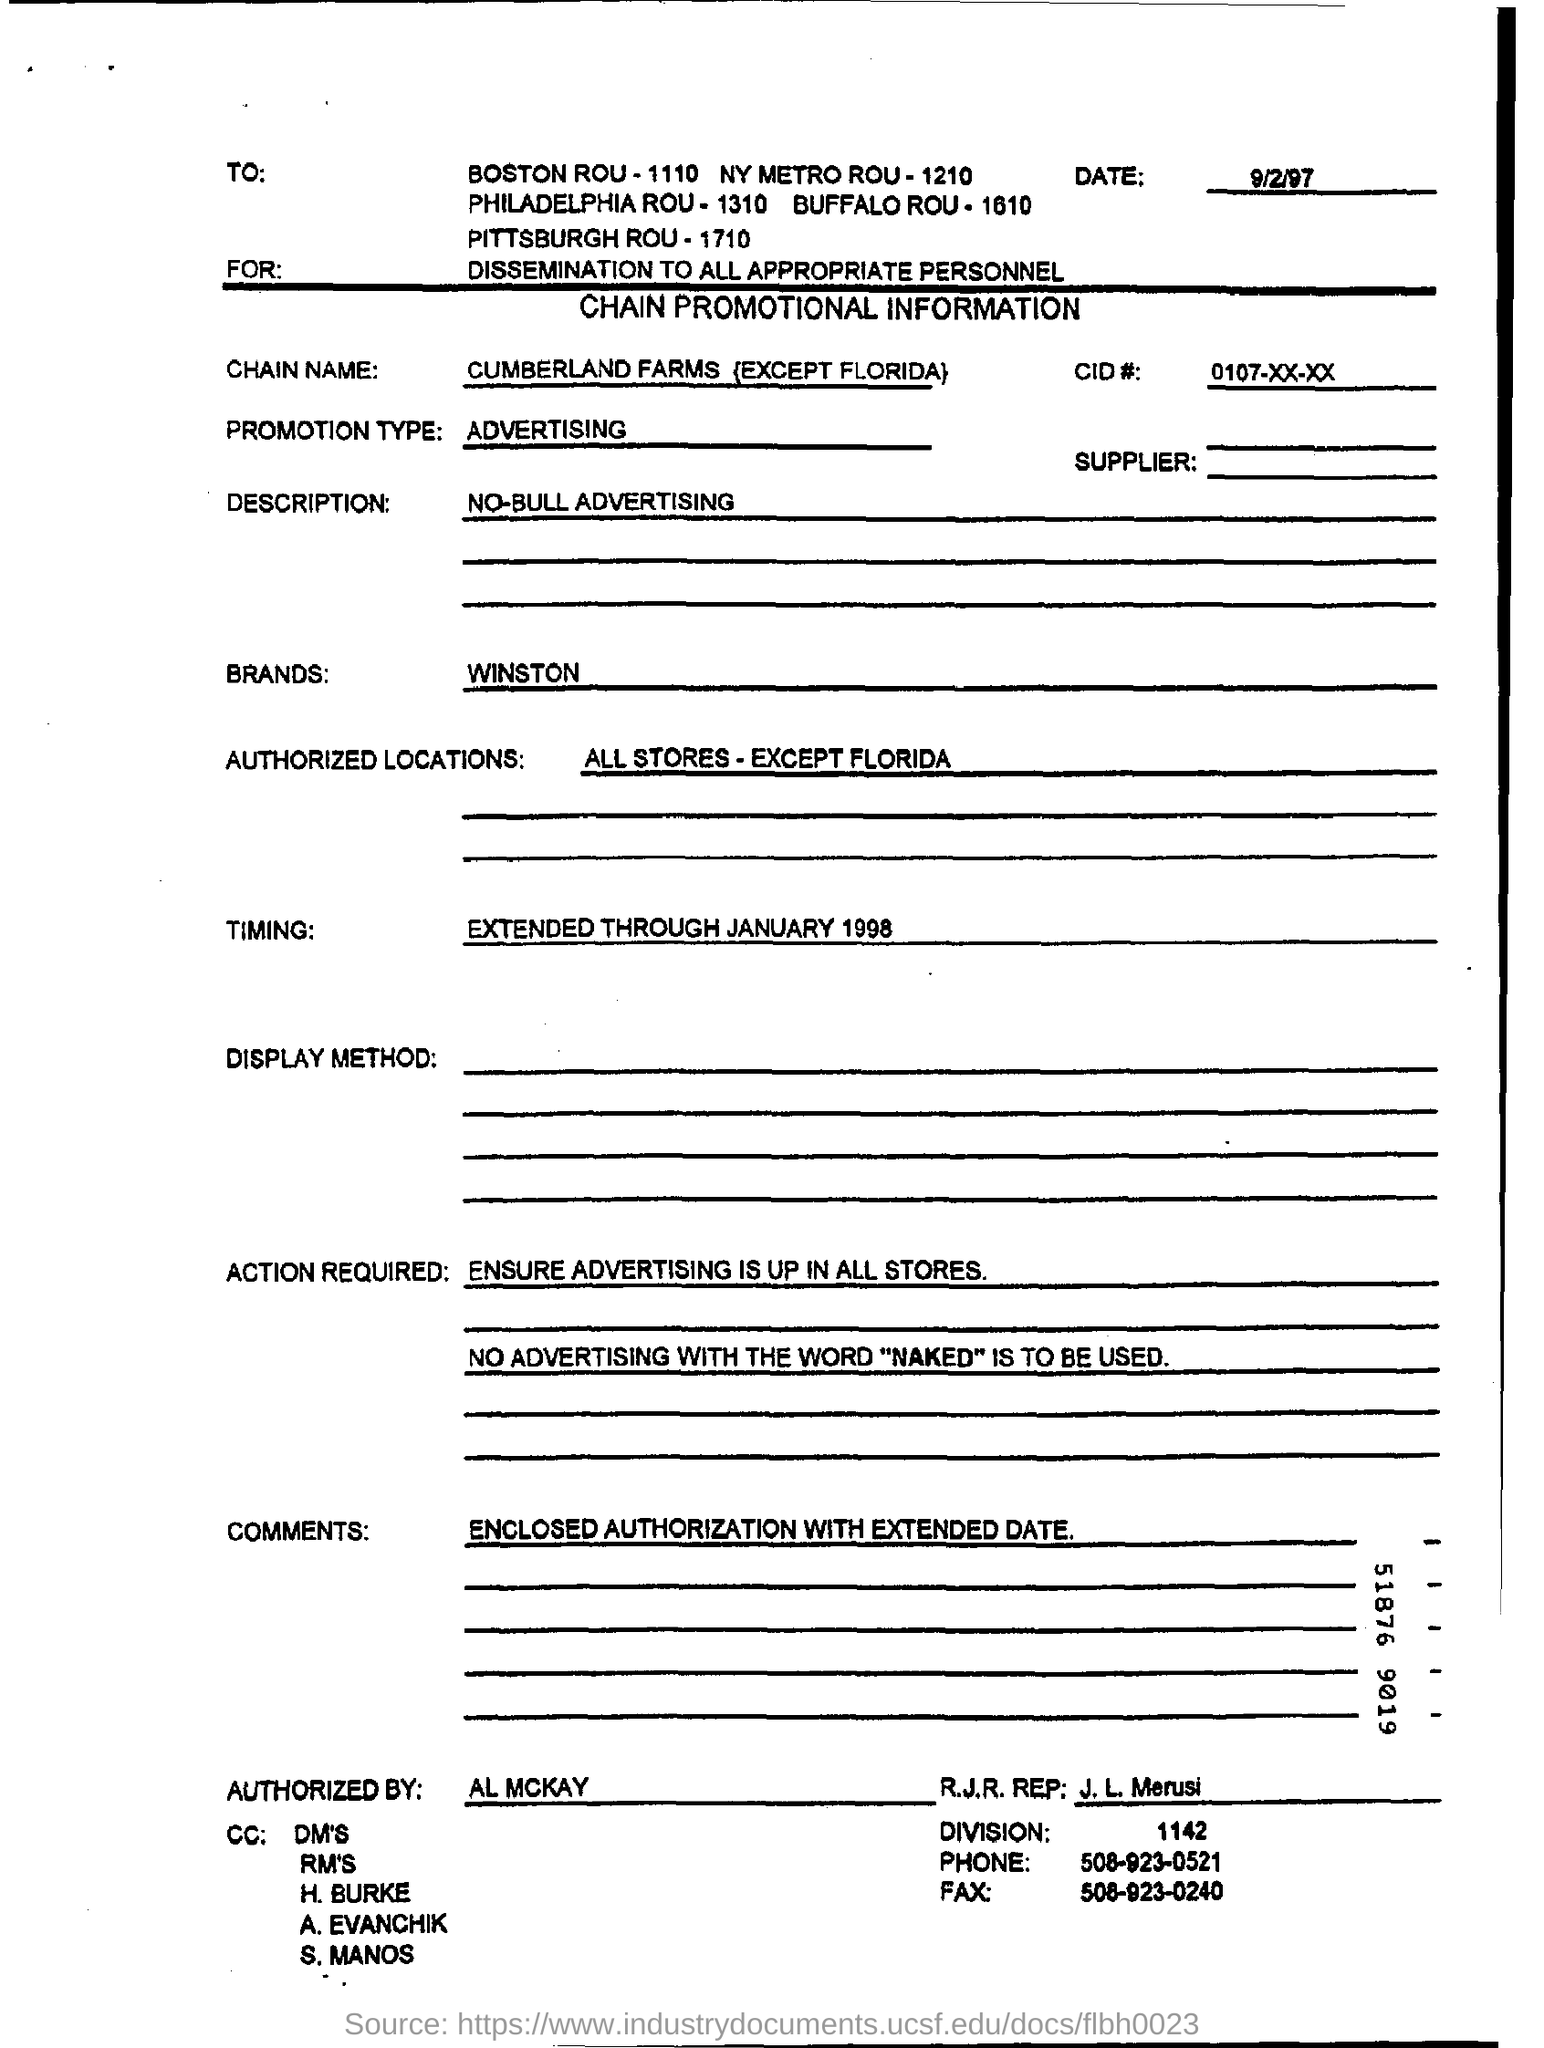What is the word prohibited in the advertisement
Give a very brief answer. Naked. When is the chain promotional information form dated?
Provide a succinct answer. 9/2/97. What type of promotion is mentioned on the form?
Your answer should be very brief. ADVERTISING. What is the extended time mentioned on the form?
Provide a succinct answer. January 1998. Who authorized the form?
Give a very brief answer. AL MCKAY. 